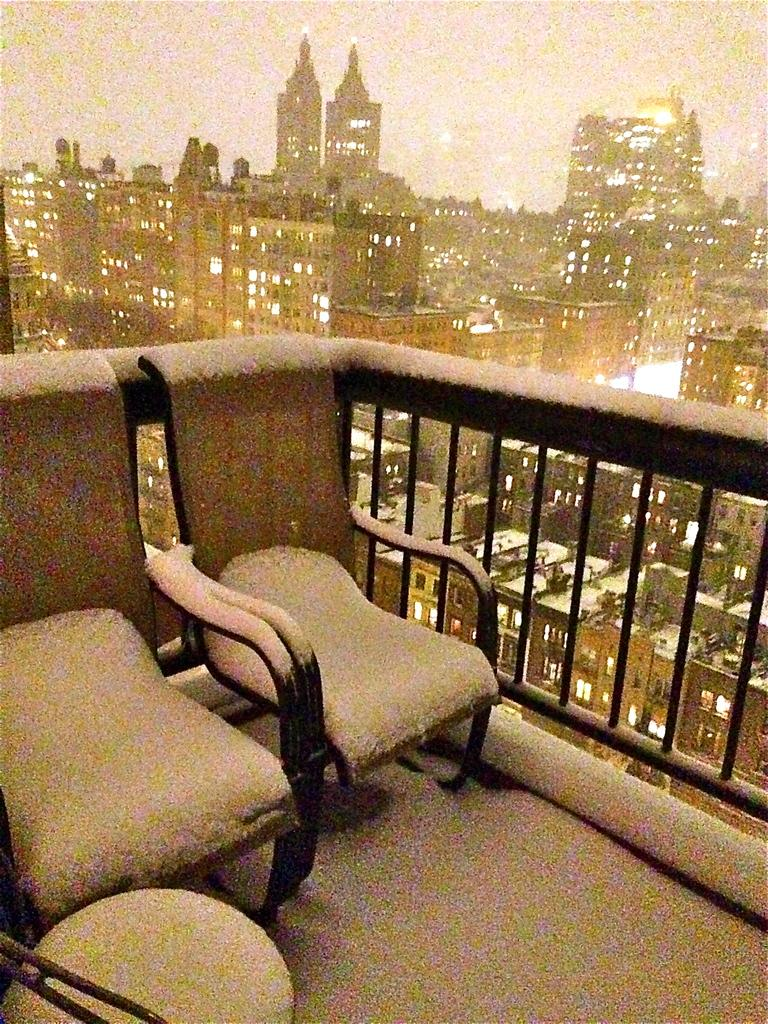What type of outdoor space is visible in the image? There is a balcony in the image. What furniture is present on the balcony? There are two sofas on the balcony. What can be seen in the background of the image? The image shows a view of a place with buildings and houses. What type of train can be seen passing by in the image? There is no train visible in the image; it only shows a balcony with sofas and a background of buildings and houses. 